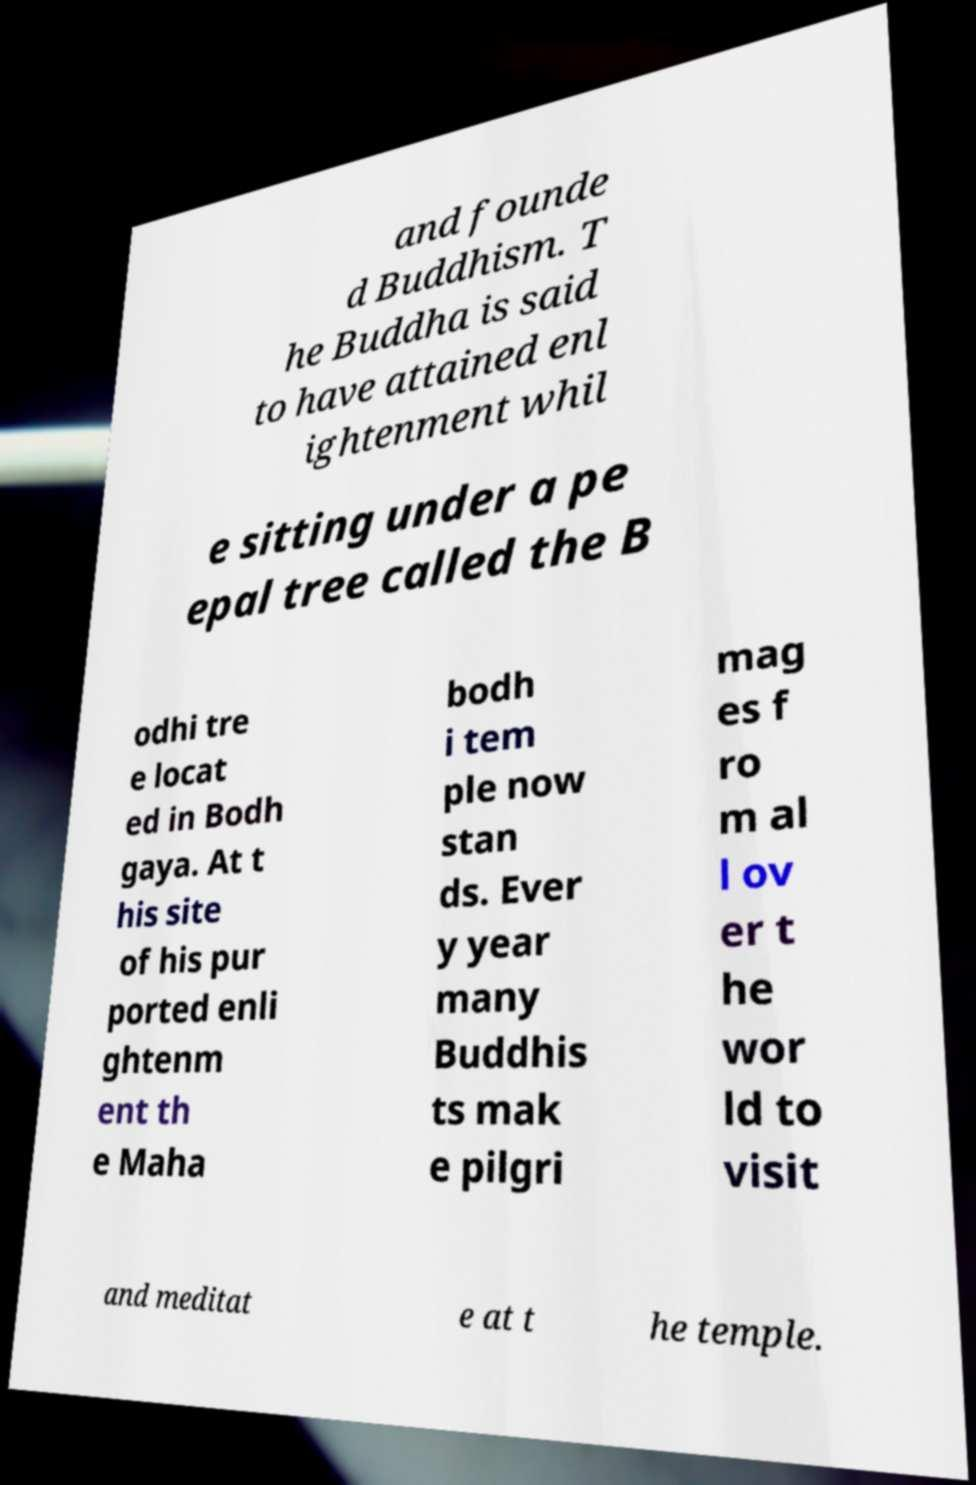Please read and relay the text visible in this image. What does it say? and founde d Buddhism. T he Buddha is said to have attained enl ightenment whil e sitting under a pe epal tree called the B odhi tre e locat ed in Bodh gaya. At t his site of his pur ported enli ghtenm ent th e Maha bodh i tem ple now stan ds. Ever y year many Buddhis ts mak e pilgri mag es f ro m al l ov er t he wor ld to visit and meditat e at t he temple. 